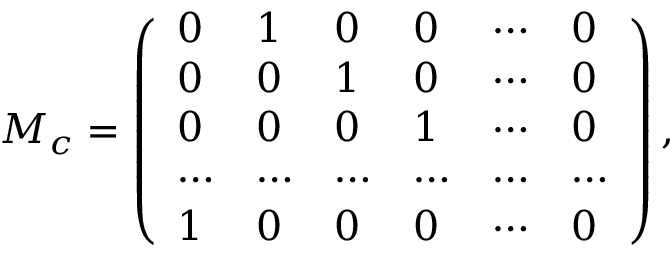<formula> <loc_0><loc_0><loc_500><loc_500>{ M _ { c } = \left ( \begin{array} { l l l l l l } { 0 } & { 1 } & { 0 } & { 0 } & { \cdots } & { 0 } \\ { 0 } & { 0 } & { 1 } & { 0 } & { \cdots } & { 0 } \\ { 0 } & { 0 } & { 0 } & { 1 } & { \cdots } & { 0 } \\ { \cdots } & { \cdots } & { \cdots } & { \cdots } & { \cdots } & { \cdots } \\ { 1 } & { 0 } & { 0 } & { 0 } & { \cdots } & { 0 } \end{array} \right ) , }</formula> 